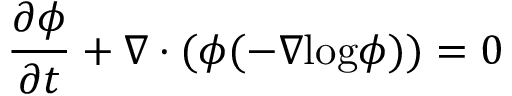Convert formula to latex. <formula><loc_0><loc_0><loc_500><loc_500>\frac { \partial \phi } { \partial t } + \nabla \cdot ( \phi ( - \nabla \log \phi ) ) = 0</formula> 